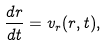<formula> <loc_0><loc_0><loc_500><loc_500>\frac { d r } { d t } = v _ { r } ( r , t ) ,</formula> 